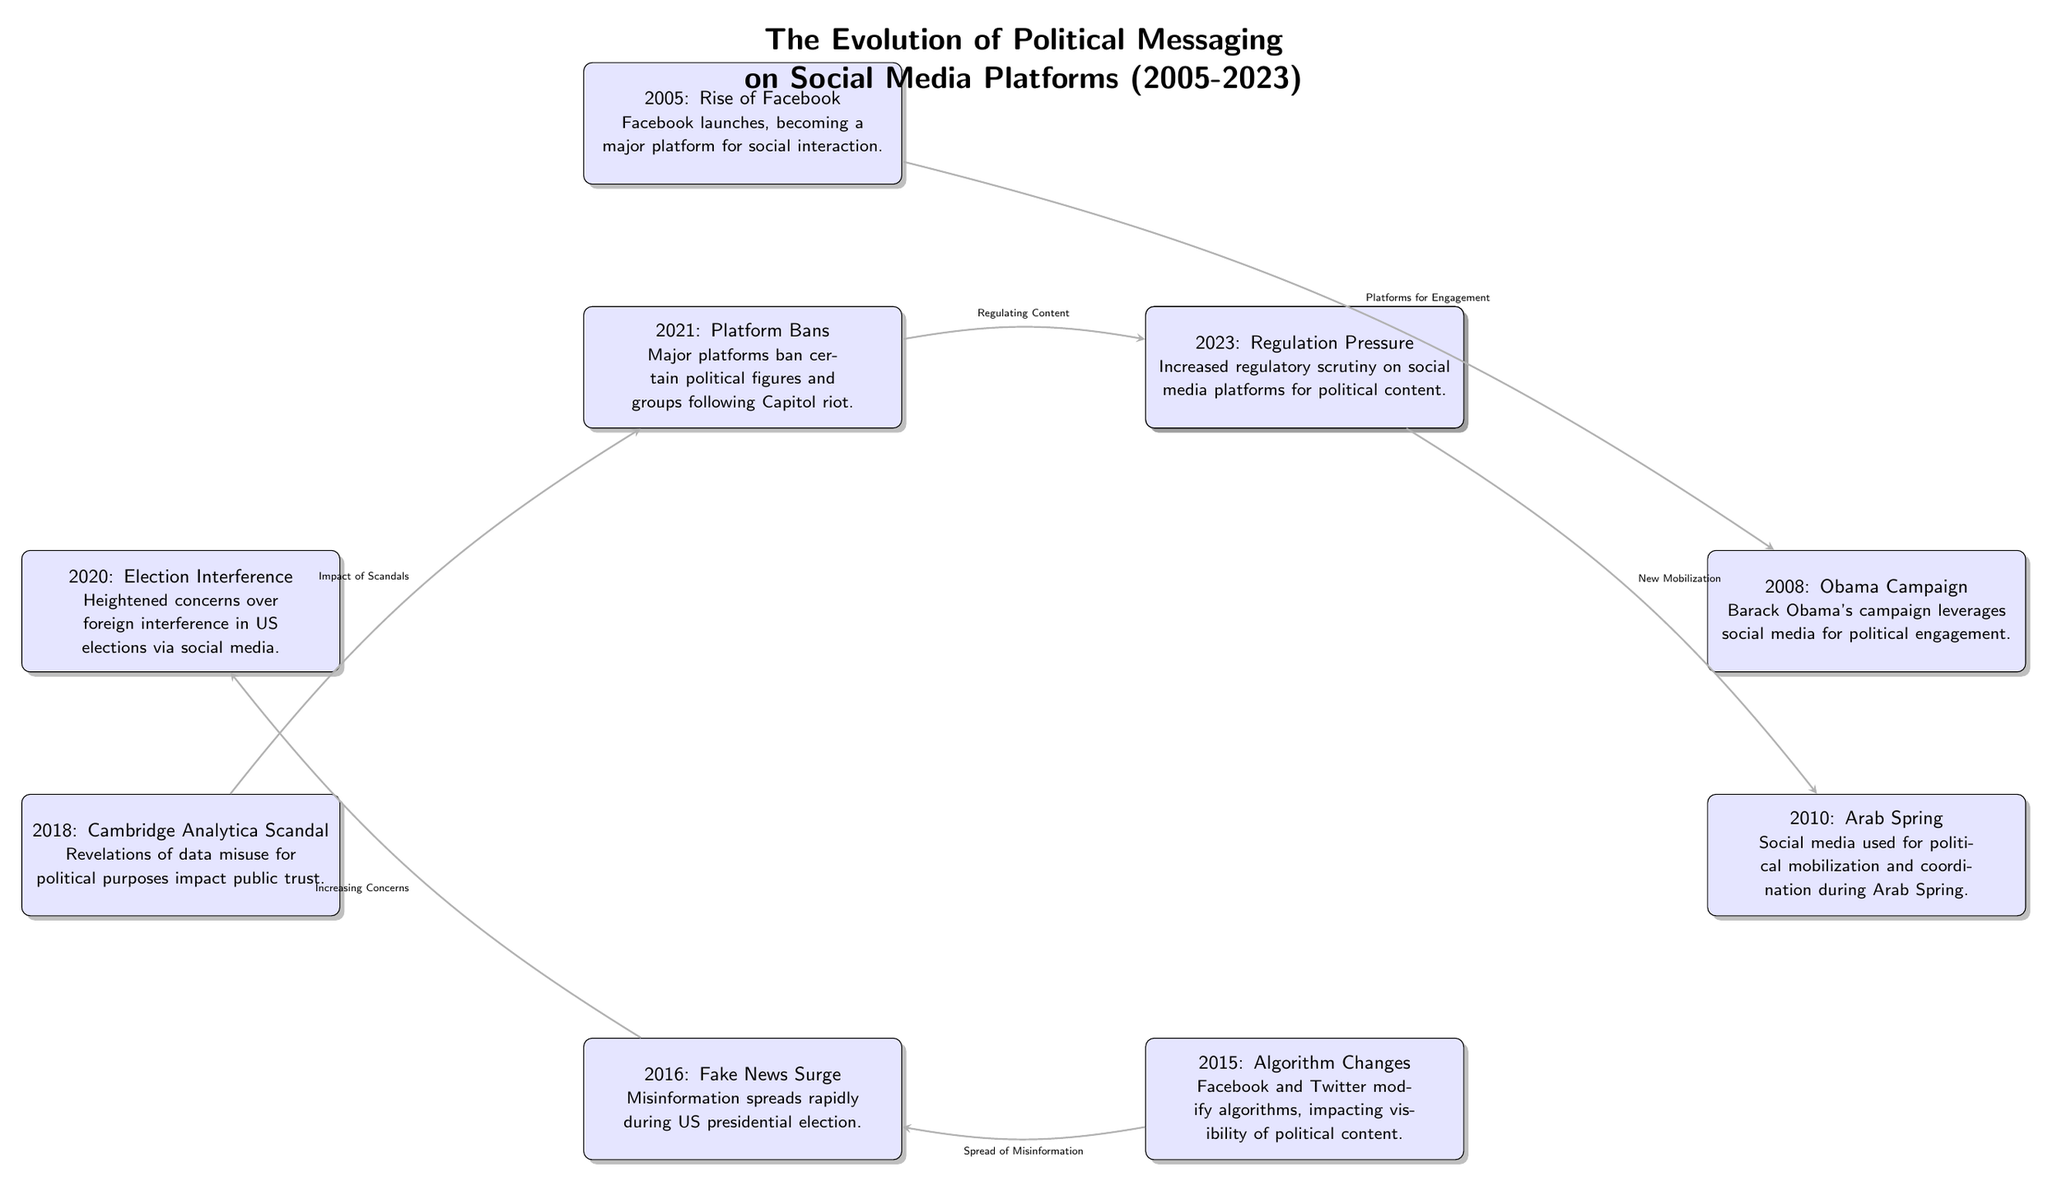What event marks the introduction of Twitter? The diagram states that Twitter was launched in 2006, which is labeled as "Twitter's Birth." This node is located under the year 2006 in the timeline.
Answer: 2006: Twitter's Birth Which event directly effects the spread of misinformation? The connection in the diagram shows that the event labeled "2015: Algorithm Changes" leads to the "2016: Fake News Surge." Therefore, the algorithm changes affected how misinformation spread.
Answer: 2015: Algorithm Changes How many key events are represented in the diagram? By counting the nodes in the diagram, there are a total of 10 key events from 2005 to 2023, represented as discrete events in the timeline.
Answer: 10 What event is associated with the rise of social media for political engagement? The event corresponding to this is "2008: Obama Campaign," indicating how social media was leveraged for political purposes during this campaign.
Answer: 2008: Obama Campaign Which year marks the Cambridge Analytica scandal's mention? The diagram specifies that the Cambridge Analytica scandal is highlighted in the year 2018, represented as "2018: Cambridge Analytica Scandal."
Answer: 2018: Cambridge Analytica Scandal What significant event occurred in 2021? The diagram depicts "2021: Platform Bans" as a major event occurring in that year, relating to actions taken by major social media platforms.
Answer: 2021: Platform Bans Which two events are linked by the connection labeled "Increasing Concerns"? The events connected by "Increasing Concerns" are "2016: Fake News Surge" and "2020: Election Interference." The connection indicates that the surge of fake news led to increased concerns about election integrity.
Answer: 2016: Fake News Surge and 2020: Election Interference What is the last event shown in the timeline? The last event in the diagram is "2023: Regulation Pressure," indicating current trends regarding the oversight of social media and its political content.
Answer: 2023: Regulation Pressure What connection follows the event related to the Cambridge Analytica scandal? The diagram indicates that the event "2018: Cambridge Analytica Scandal" leads to the connection labeled "Impact of Scandals," which then leads to "2021: Platform Bans."
Answer: Impact of Scandals 